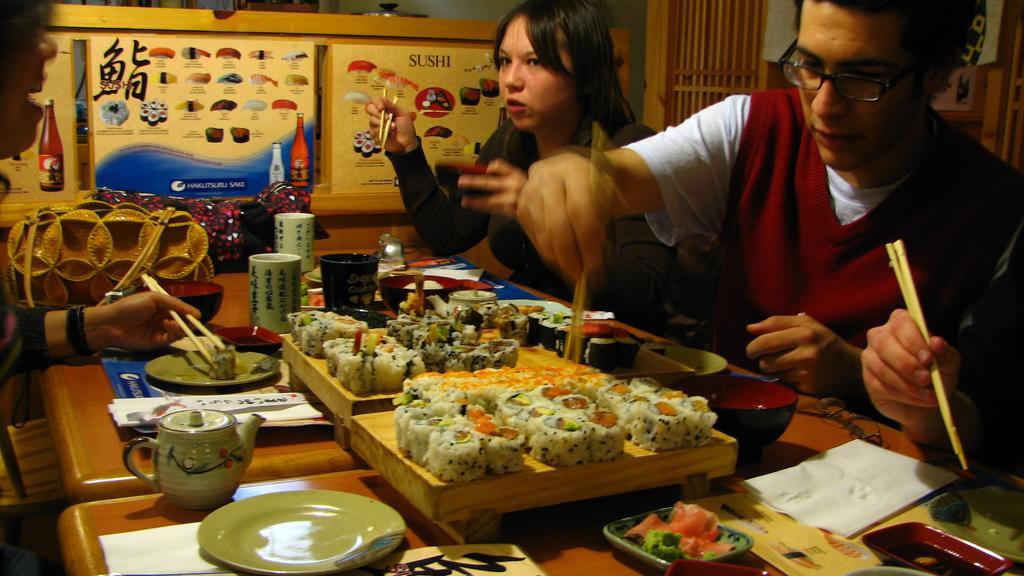In one or two sentences, can you explain what this image depicts? In this image I see few people who are sitting and they are holding the chopsticks in their hands and there are tables in front of them on which there is food. 